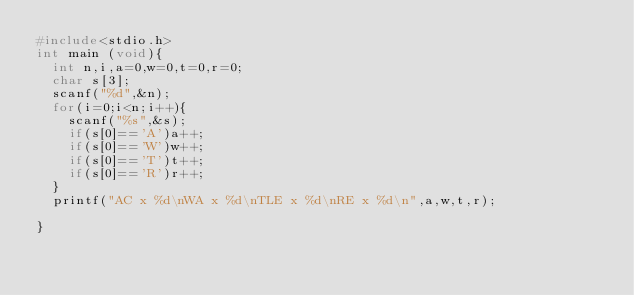Convert code to text. <code><loc_0><loc_0><loc_500><loc_500><_C_>#include<stdio.h>
int main (void){
  int n,i,a=0,w=0,t=0,r=0;
  char s[3];
  scanf("%d",&n);
  for(i=0;i<n;i++){
    scanf("%s",&s);
    if(s[0]=='A')a++;
    if(s[0]=='W')w++;
    if(s[0]=='T')t++;
    if(s[0]=='R')r++;
  }
  printf("AC x %d\nWA x %d\nTLE x %d\nRE x %d\n",a,w,t,r);
  
}</code> 